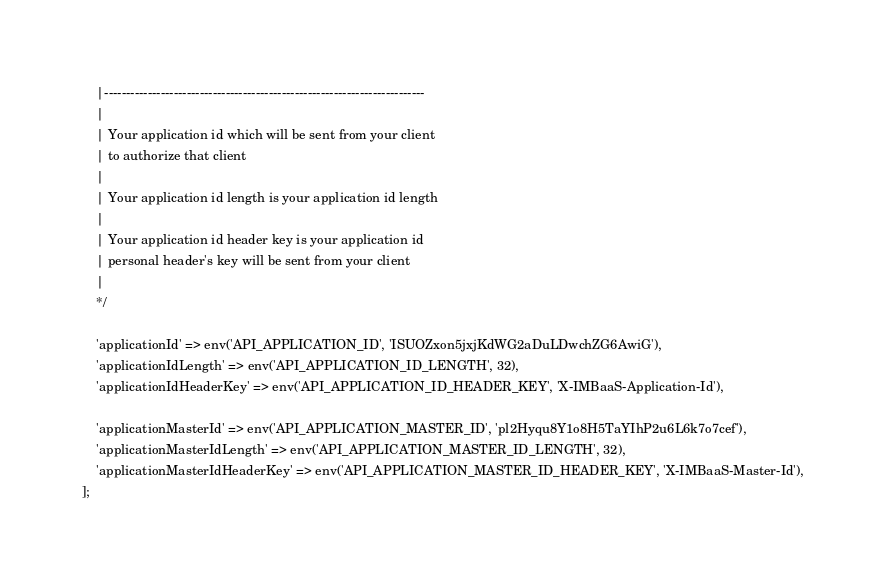<code> <loc_0><loc_0><loc_500><loc_500><_PHP_>    |--------------------------------------------------------------------------
    |
    | Your application id which will be sent from your client
    | to authorize that client
    |
    | Your application id length is your application id length
    |
    | Your application id header key is your application id
    | personal header's key will be sent from your client
    |
    */

    'applicationId' => env('API_APPLICATION_ID', 'ISUOZxon5jxjKdWG2aDuLDwchZG6AwiG'),
    'applicationIdLength' => env('API_APPLICATION_ID_LENGTH', 32),
    'applicationIdHeaderKey' => env('API_APPLICATION_ID_HEADER_KEY', 'X-IMBaaS-Application-Id'),

    'applicationMasterId' => env('API_APPLICATION_MASTER_ID', 'pl2Hyqu8Y1o8H5TaYIhP2u6L6k7o7cef'),
    'applicationMasterIdLength' => env('API_APPLICATION_MASTER_ID_LENGTH', 32),
    'applicationMasterIdHeaderKey' => env('API_APPLICATION_MASTER_ID_HEADER_KEY', 'X-IMBaaS-Master-Id'),
];</code> 